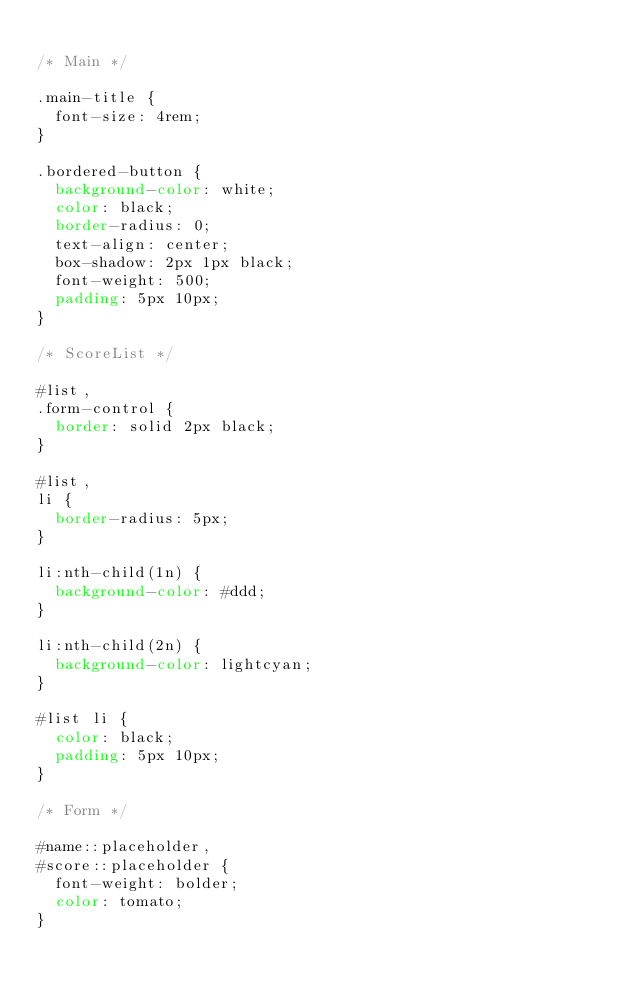<code> <loc_0><loc_0><loc_500><loc_500><_CSS_>
/* Main */

.main-title {
  font-size: 4rem;
}

.bordered-button {
  background-color: white;
  color: black;
  border-radius: 0;
  text-align: center;
  box-shadow: 2px 1px black;
  font-weight: 500;
  padding: 5px 10px;
}

/* ScoreList */

#list,
.form-control {
  border: solid 2px black;
}

#list,
li {
  border-radius: 5px;
}

li:nth-child(1n) {
  background-color: #ddd;
}

li:nth-child(2n) {
  background-color: lightcyan;
}

#list li {
  color: black;
  padding: 5px 10px;
}

/* Form */

#name::placeholder,
#score::placeholder {
  font-weight: bolder;
  color: tomato;
}
</code> 